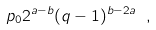<formula> <loc_0><loc_0><loc_500><loc_500>p _ { 0 } 2 ^ { a - b } ( q - 1 ) ^ { b - 2 a } \ ,</formula> 